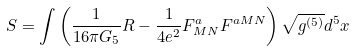Convert formula to latex. <formula><loc_0><loc_0><loc_500><loc_500>S = \int \left ( \frac { 1 } { 1 6 \pi G _ { 5 } } R - \frac { 1 } { 4 e ^ { 2 } } F ^ { a } _ { M N } F ^ { a M N } \right ) \sqrt { g ^ { ( 5 ) } } d ^ { 5 } x</formula> 